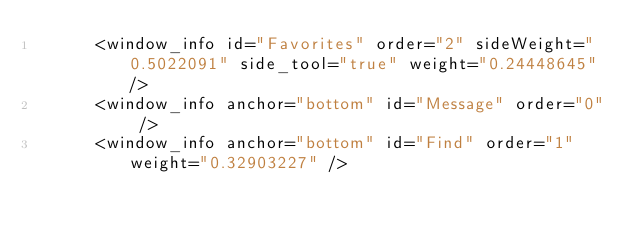<code> <loc_0><loc_0><loc_500><loc_500><_XML_>      <window_info id="Favorites" order="2" sideWeight="0.5022091" side_tool="true" weight="0.24448645" />
      <window_info anchor="bottom" id="Message" order="0" />
      <window_info anchor="bottom" id="Find" order="1" weight="0.32903227" /></code> 